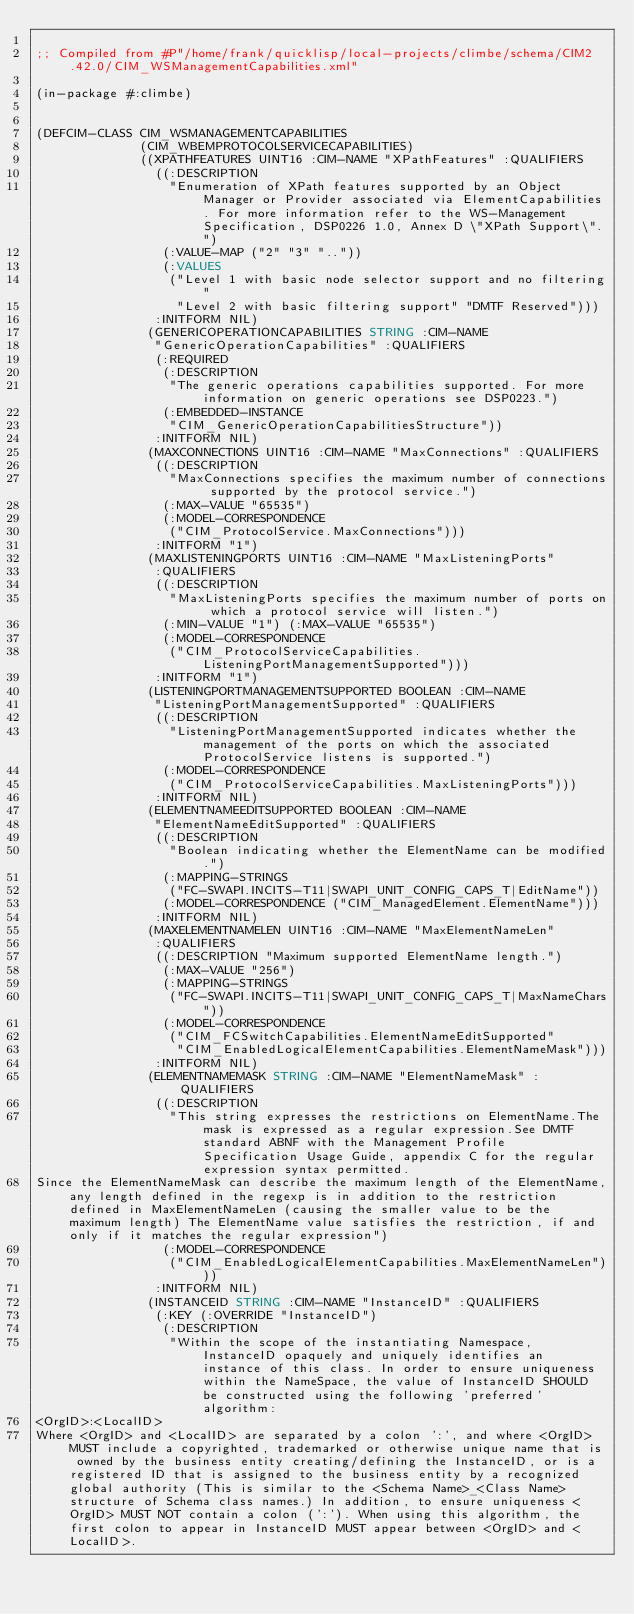Convert code to text. <code><loc_0><loc_0><loc_500><loc_500><_Lisp_>
;; Compiled from #P"/home/frank/quicklisp/local-projects/climbe/schema/CIM2.42.0/CIM_WSManagementCapabilities.xml"

(in-package #:climbe)


(DEFCIM-CLASS CIM_WSMANAGEMENTCAPABILITIES
              (CIM_WBEMPROTOCOLSERVICECAPABILITIES)
              ((XPATHFEATURES UINT16 :CIM-NAME "XPathFeatures" :QUALIFIERS
                ((:DESCRIPTION
                  "Enumeration of XPath features supported by an Object Manager or Provider associated via ElementCapabilities. For more information refer to the WS-Management Specification, DSP0226 1.0, Annex D \"XPath Support\".")
                 (:VALUE-MAP ("2" "3" ".."))
                 (:VALUES
                  ("Level 1 with basic node selector support and no filtering"
                   "Level 2 with basic filtering support" "DMTF Reserved")))
                :INITFORM NIL)
               (GENERICOPERATIONCAPABILITIES STRING :CIM-NAME
                "GenericOperationCapabilities" :QUALIFIERS
                (:REQUIRED
                 (:DESCRIPTION
                  "The generic operations capabilities supported. For more information on generic operations see DSP0223.")
                 (:EMBEDDED-INSTANCE
                  "CIM_GenericOperationCapabilitiesStructure"))
                :INITFORM NIL)
               (MAXCONNECTIONS UINT16 :CIM-NAME "MaxConnections" :QUALIFIERS
                ((:DESCRIPTION
                  "MaxConnections specifies the maximum number of connections supported by the protocol service.")
                 (:MAX-VALUE "65535")
                 (:MODEL-CORRESPONDENCE
                  ("CIM_ProtocolService.MaxConnections")))
                :INITFORM "1")
               (MAXLISTENINGPORTS UINT16 :CIM-NAME "MaxListeningPorts"
                :QUALIFIERS
                ((:DESCRIPTION
                  "MaxListeningPorts specifies the maximum number of ports on which a protocol service will listen.")
                 (:MIN-VALUE "1") (:MAX-VALUE "65535")
                 (:MODEL-CORRESPONDENCE
                  ("CIM_ProtocolServiceCapabilities.ListeningPortManagementSupported")))
                :INITFORM "1")
               (LISTENINGPORTMANAGEMENTSUPPORTED BOOLEAN :CIM-NAME
                "ListeningPortManagementSupported" :QUALIFIERS
                ((:DESCRIPTION
                  "ListeningPortManagementSupported indicates whether the management of the ports on which the associated ProtocolService listens is supported.")
                 (:MODEL-CORRESPONDENCE
                  ("CIM_ProtocolServiceCapabilities.MaxListeningPorts")))
                :INITFORM NIL)
               (ELEMENTNAMEEDITSUPPORTED BOOLEAN :CIM-NAME
                "ElementNameEditSupported" :QUALIFIERS
                ((:DESCRIPTION
                  "Boolean indicating whether the ElementName can be modified.")
                 (:MAPPING-STRINGS
                  ("FC-SWAPI.INCITS-T11|SWAPI_UNIT_CONFIG_CAPS_T|EditName"))
                 (:MODEL-CORRESPONDENCE ("CIM_ManagedElement.ElementName")))
                :INITFORM NIL)
               (MAXELEMENTNAMELEN UINT16 :CIM-NAME "MaxElementNameLen"
                :QUALIFIERS
                ((:DESCRIPTION "Maximum supported ElementName length.")
                 (:MAX-VALUE "256")
                 (:MAPPING-STRINGS
                  ("FC-SWAPI.INCITS-T11|SWAPI_UNIT_CONFIG_CAPS_T|MaxNameChars"))
                 (:MODEL-CORRESPONDENCE
                  ("CIM_FCSwitchCapabilities.ElementNameEditSupported"
                   "CIM_EnabledLogicalElementCapabilities.ElementNameMask")))
                :INITFORM NIL)
               (ELEMENTNAMEMASK STRING :CIM-NAME "ElementNameMask" :QUALIFIERS
                ((:DESCRIPTION
                  "This string expresses the restrictions on ElementName.The mask is expressed as a regular expression.See DMTF standard ABNF with the Management Profile Specification Usage Guide, appendix C for the regular expression syntax permitted. 
Since the ElementNameMask can describe the maximum length of the ElementName,any length defined in the regexp is in addition to the restriction defined in MaxElementNameLen (causing the smaller value to be the maximum length) The ElementName value satisfies the restriction, if and only if it matches the regular expression")
                 (:MODEL-CORRESPONDENCE
                  ("CIM_EnabledLogicalElementCapabilities.MaxElementNameLen")))
                :INITFORM NIL)
               (INSTANCEID STRING :CIM-NAME "InstanceID" :QUALIFIERS
                (:KEY (:OVERRIDE "InstanceID")
                 (:DESCRIPTION
                  "Within the scope of the instantiating Namespace, InstanceID opaquely and uniquely identifies an instance of this class. In order to ensure uniqueness within the NameSpace, the value of InstanceID SHOULD be constructed using the following 'preferred' algorithm: 
<OrgID>:<LocalID> 
Where <OrgID> and <LocalID> are separated by a colon ':', and where <OrgID> MUST include a copyrighted, trademarked or otherwise unique name that is owned by the business entity creating/defining the InstanceID, or is a registered ID that is assigned to the business entity by a recognized global authority (This is similar to the <Schema Name>_<Class Name> structure of Schema class names.) In addition, to ensure uniqueness <OrgID> MUST NOT contain a colon (':'). When using this algorithm, the first colon to appear in InstanceID MUST appear between <OrgID> and <LocalID>. </code> 